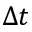Convert formula to latex. <formula><loc_0><loc_0><loc_500><loc_500>\Delta t</formula> 